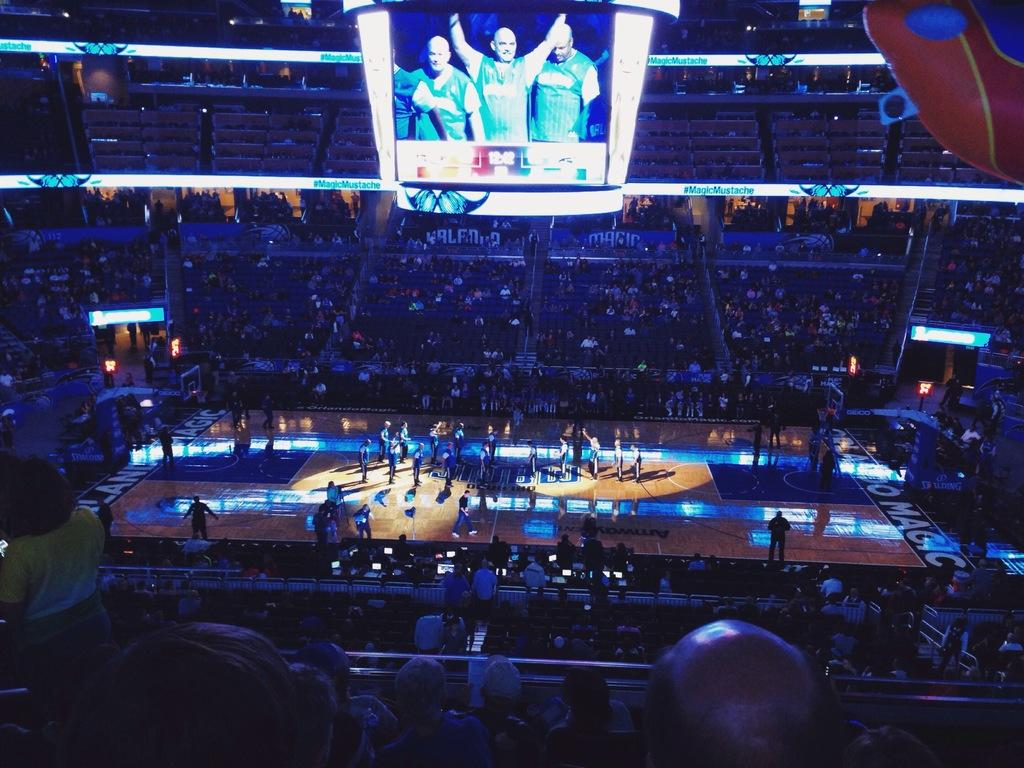What type of space is depicted in the image? The image contains an auditorium. Are there any people present in the auditorium? Yes, there are people visible in the auditorium. What is one feature of the auditorium? There is a screen in the auditorium. What is being displayed on the screen? The screen displays people. Can you tell me how many cacti are visible in the image? There are no cacti present in the image; it features an auditorium with a screen displaying people. 